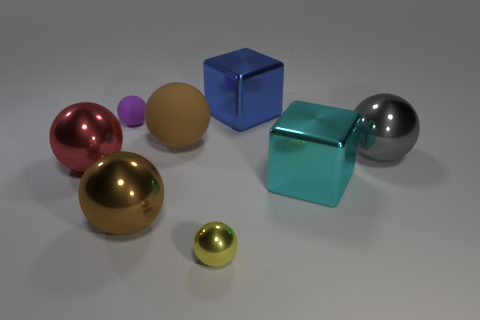There is a big shiny object that is both to the right of the big rubber object and in front of the big red metallic thing; what is its color?
Your answer should be compact. Cyan. How many big gray objects are left of the small metallic object?
Make the answer very short. 0. How many objects are either tiny cyan cylinders or shiny blocks that are in front of the gray object?
Provide a succinct answer. 1. There is a big cube in front of the tiny purple object; is there a block that is left of it?
Your answer should be compact. Yes. What color is the big metallic thing that is right of the large cyan metallic thing?
Your answer should be very brief. Gray. Is the number of brown shiny balls that are in front of the yellow shiny ball the same as the number of large gray shiny balls?
Your answer should be very brief. No. What shape is the large metallic object that is on the left side of the blue metal cube and in front of the red shiny ball?
Your answer should be very brief. Sphere. The tiny matte object that is the same shape as the brown shiny object is what color?
Your response must be concise. Purple. Is there anything else that is the same color as the small rubber ball?
Keep it short and to the point. No. There is a yellow shiny thing that is in front of the large red thing in front of the tiny object that is behind the small yellow metal ball; what is its shape?
Your answer should be very brief. Sphere. 